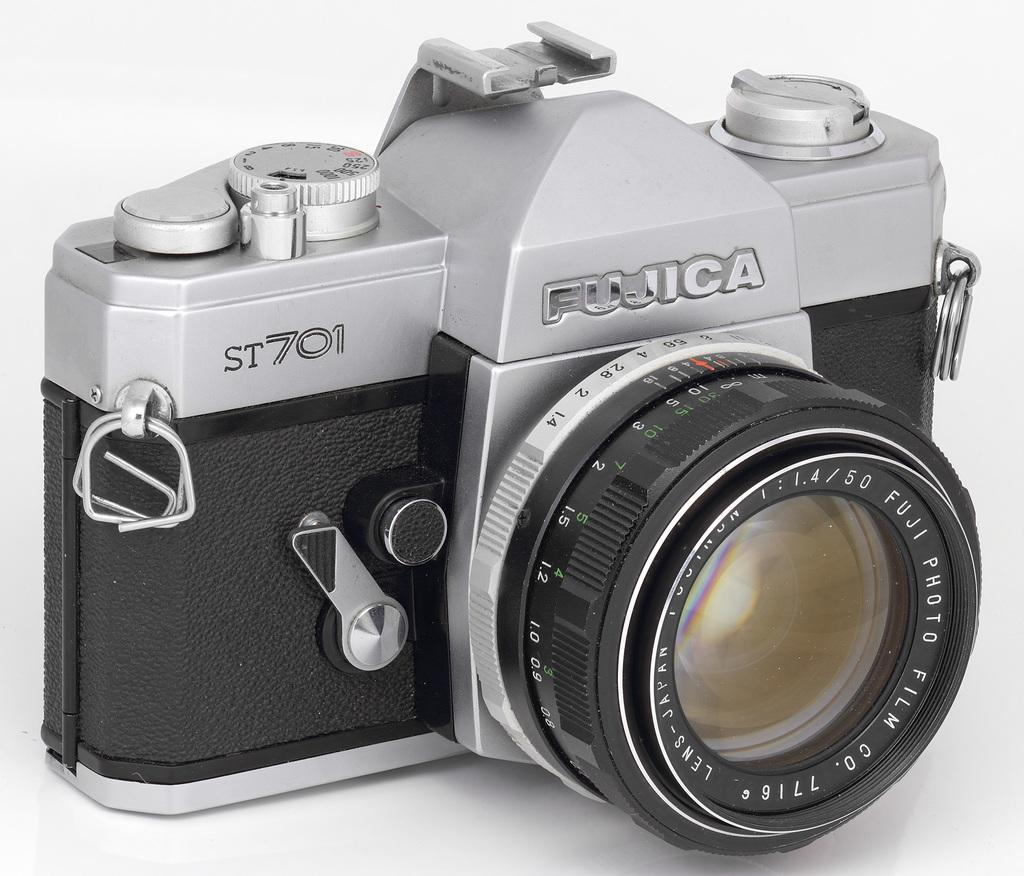<image>
Provide a brief description of the given image. A black and silver Fujica camera sitting in front of a white background. 